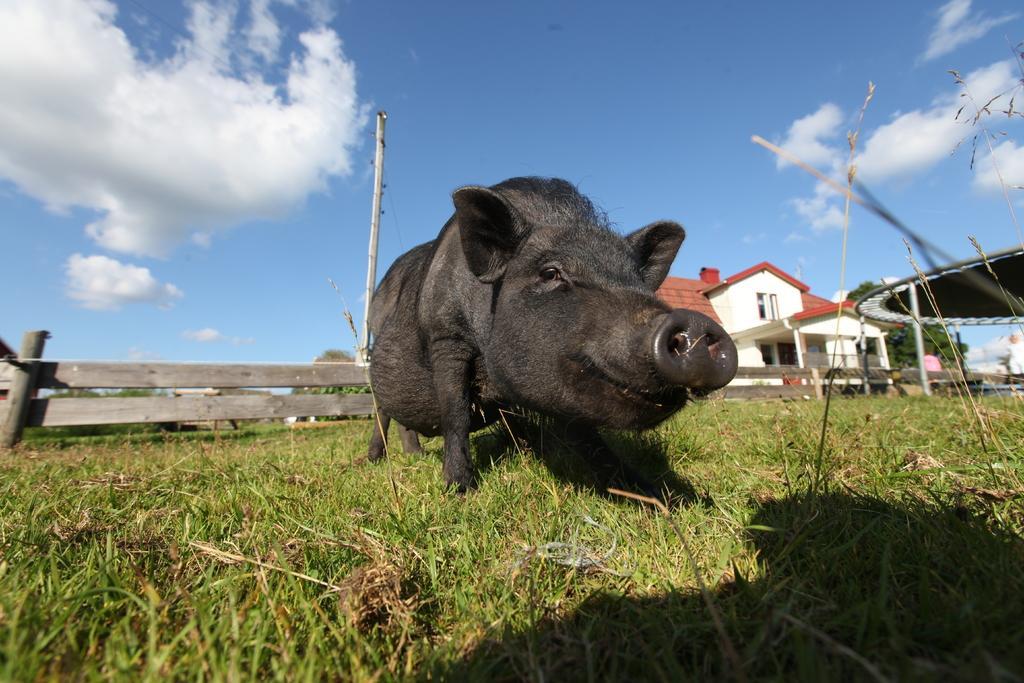Describe this image in one or two sentences. We can see pig on grass. On the background we can see house,wooden fence,wooden pole,tree and sky. 